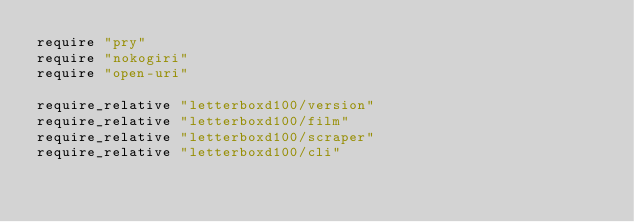Convert code to text. <code><loc_0><loc_0><loc_500><loc_500><_Ruby_>require "pry"
require "nokogiri"
require "open-uri"

require_relative "letterboxd100/version"
require_relative "letterboxd100/film"
require_relative "letterboxd100/scraper"
require_relative "letterboxd100/cli"</code> 